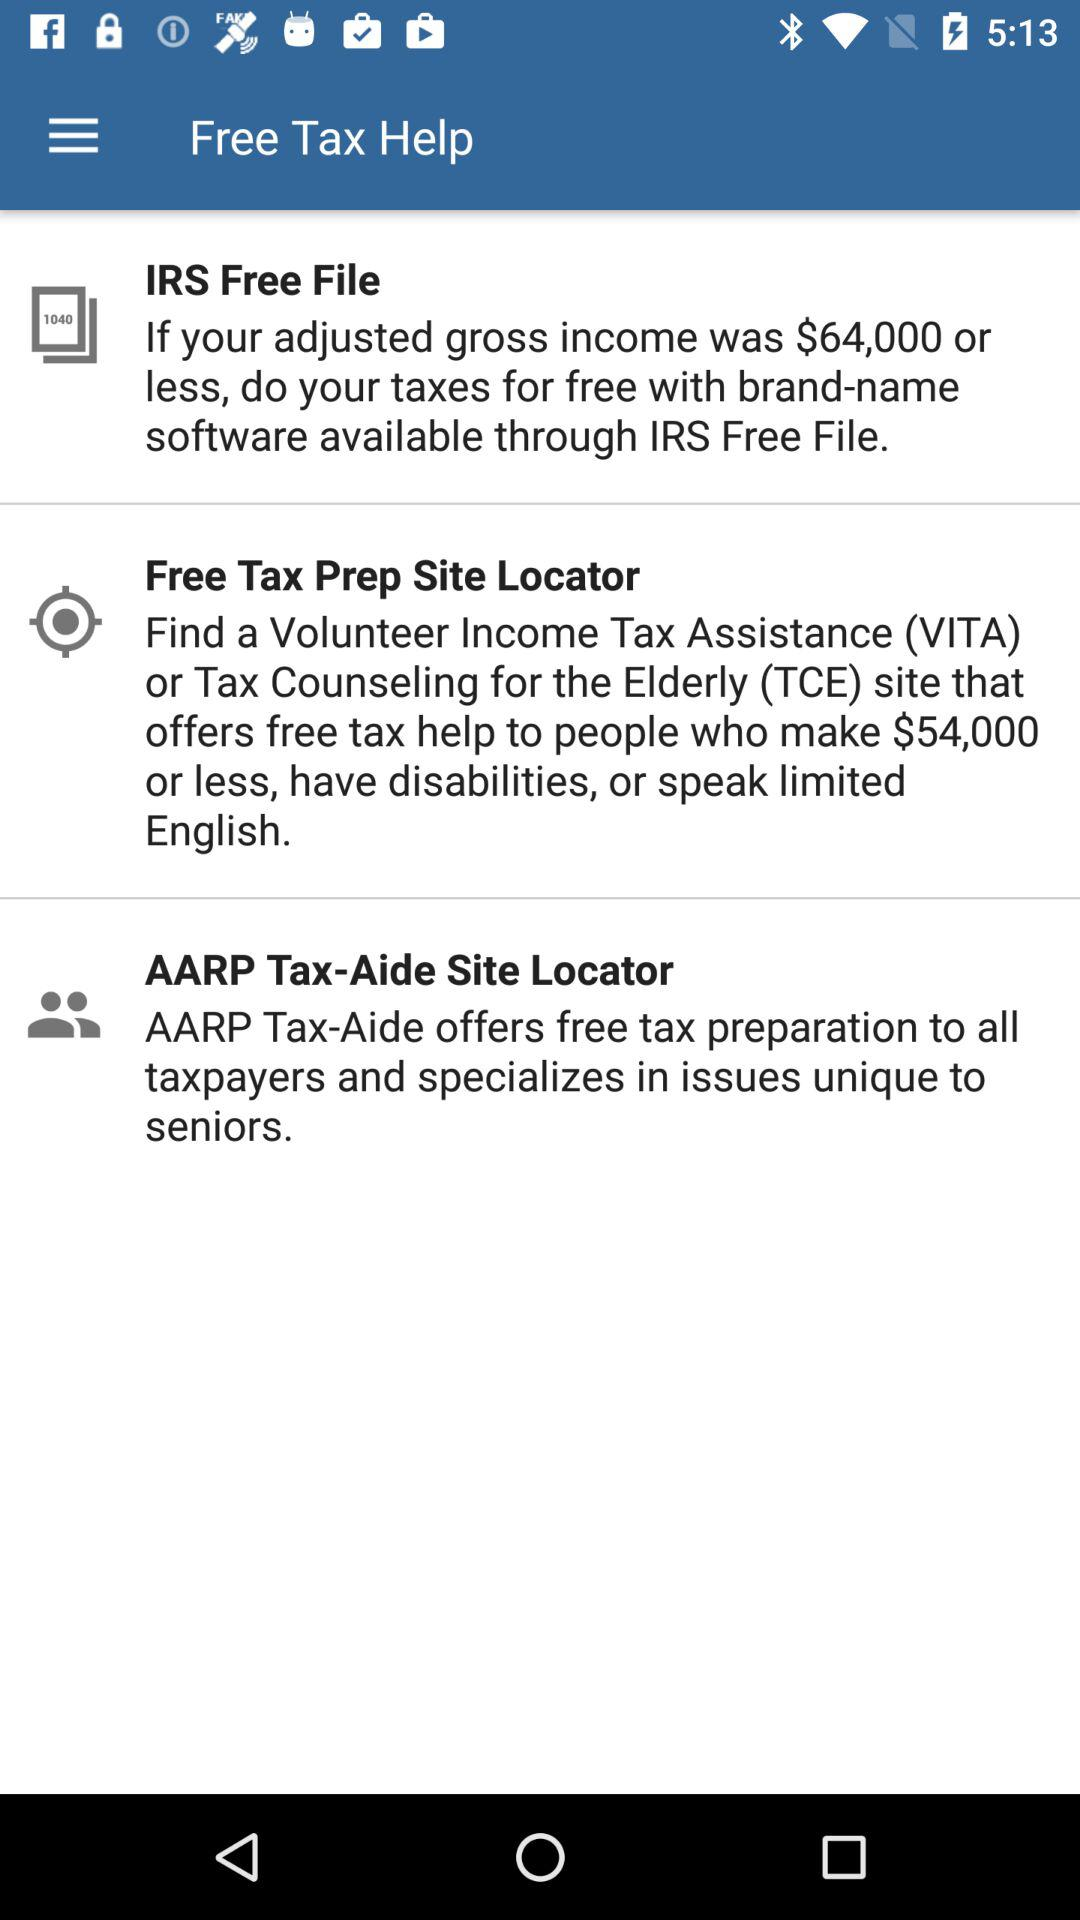What is the application name?
When the provided information is insufficient, respond with <no answer>. <no answer> 